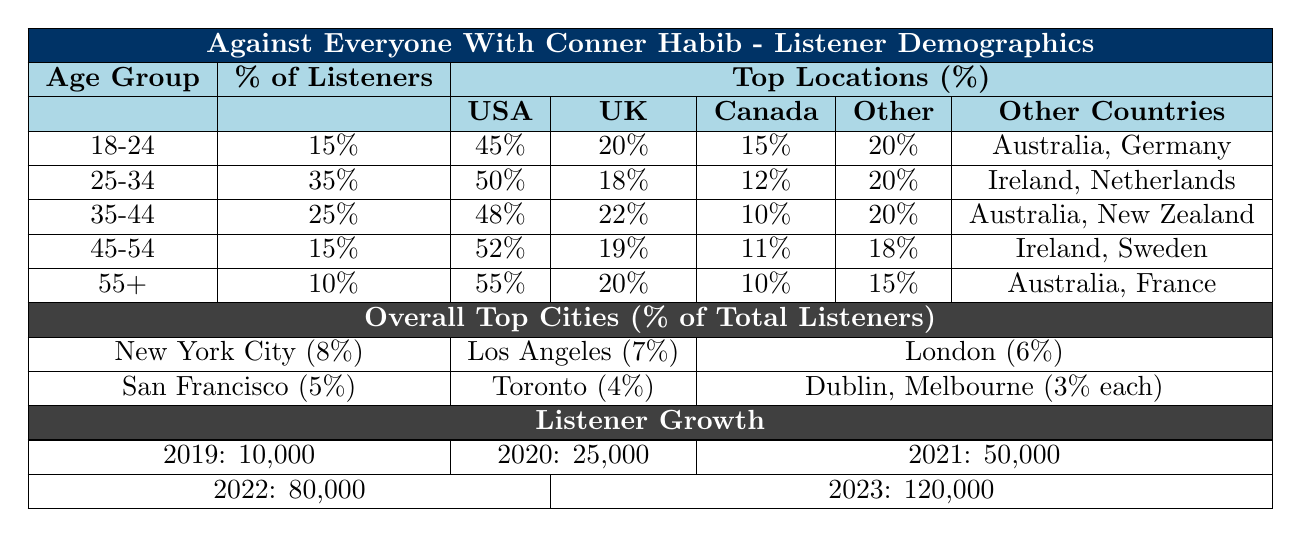What percentage of listeners are aged 25-34? The table shows that the percentage of listeners in the 25-34 age group is directly listed. It states that 35% of the audience belongs to this age group.
Answer: 35% Which country has the highest percentage of listeners in the 18-24 age group? Looking at the "Top Locations" for the 18-24 age group, the United States has the highest percentage of 45%.
Answer: United States What is the combined percentage of listeners aged 35-44 and 45-54? To find the combined percentage, add the percentages of the two age groups: 25% (35-44) + 15% (45-54) = 40%.
Answer: 40% Is the percentage of listeners aged 55+ greater than those aged 18-24? The percentage of listeners aged 55+ is 10%, while for those aged 18-24 it is 15%. Since 10% is not greater than 15%, the statement is false.
Answer: No Which country has a higher percentage of listeners in the 35-44 age group, Canada or Australia? Comparing the percentages for the 35-44 age group, Canada has 10% and Australia has 8%. Since 10% is greater than 8%, Canada has a higher percentage.
Answer: Canada How many listeners were there in 2021 compared to 2022? There were 50,000 listeners in 2021 and 80,000 in 2022. To compare, you can take the difference: 80,000 - 50,000 = 30,000 more listeners in 2022.
Answer: 30,000 Which age group has the lowest percentage of listeners? The lowest percentage is found in the 55+ age group, which has 10%.
Answer: 55+ Calculate the total percentage of listeners from the United States across all age groups. The United States percentages are: 45% (18-24) + 50% (25-34) + 48% (35-44) + 52% (45-54) + 55% (55+) = 250%. To find the total, we sum these values: 250% total.
Answer: 250% Are there more listeners aged 45-54 from the UK than from Canada? The UK has 19% of listeners aged 45-54, while Canada has 11%. Since 19% is greater than 11%, the statement is true.
Answer: Yes What percentage of listeners aged 18-24 are from other countries aside from the US, UK, Canada, and Australia? For the 18-24 age group, the percentage from "Other Countries" is given as 5%.
Answer: 5% 